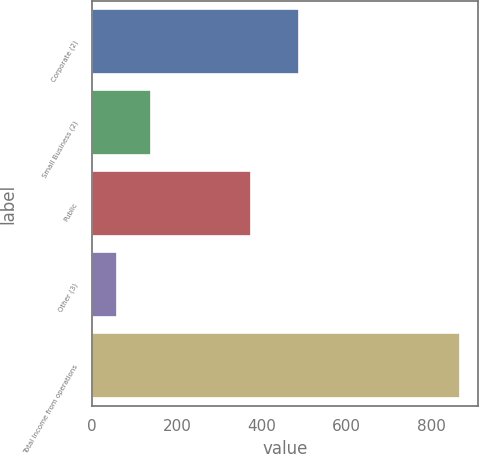<chart> <loc_0><loc_0><loc_500><loc_500><bar_chart><fcel>Corporate (2)<fcel>Small Business (2)<fcel>Public<fcel>Other (3)<fcel>Total Income from operations<nl><fcel>487<fcel>138.72<fcel>374<fcel>57.9<fcel>866.1<nl></chart> 